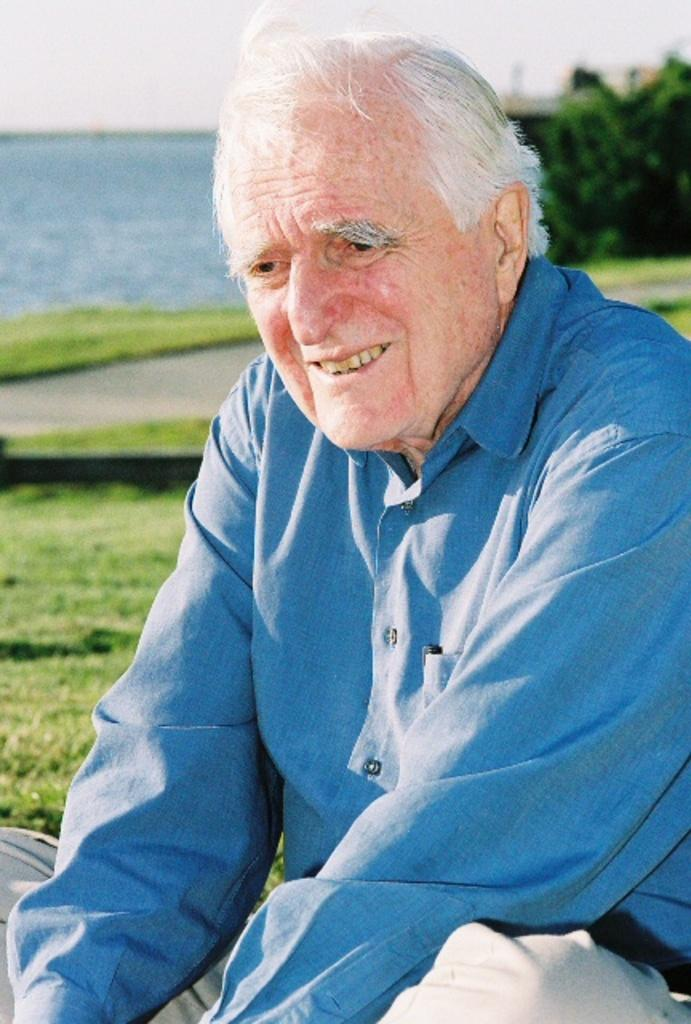What is the man in the image doing? The man is sitting on the ground in the image. What is the surface the man is sitting on? The ground is covered with grass. What can be seen behind the man in the image? There is water visible behind the man. What color is the chalk the man is holding in the image? There is no chalk present in the image. How many wheels can be seen on the man's vehicle in the image? There is no vehicle present in the image, so it is not possible to determine the number of wheels. 